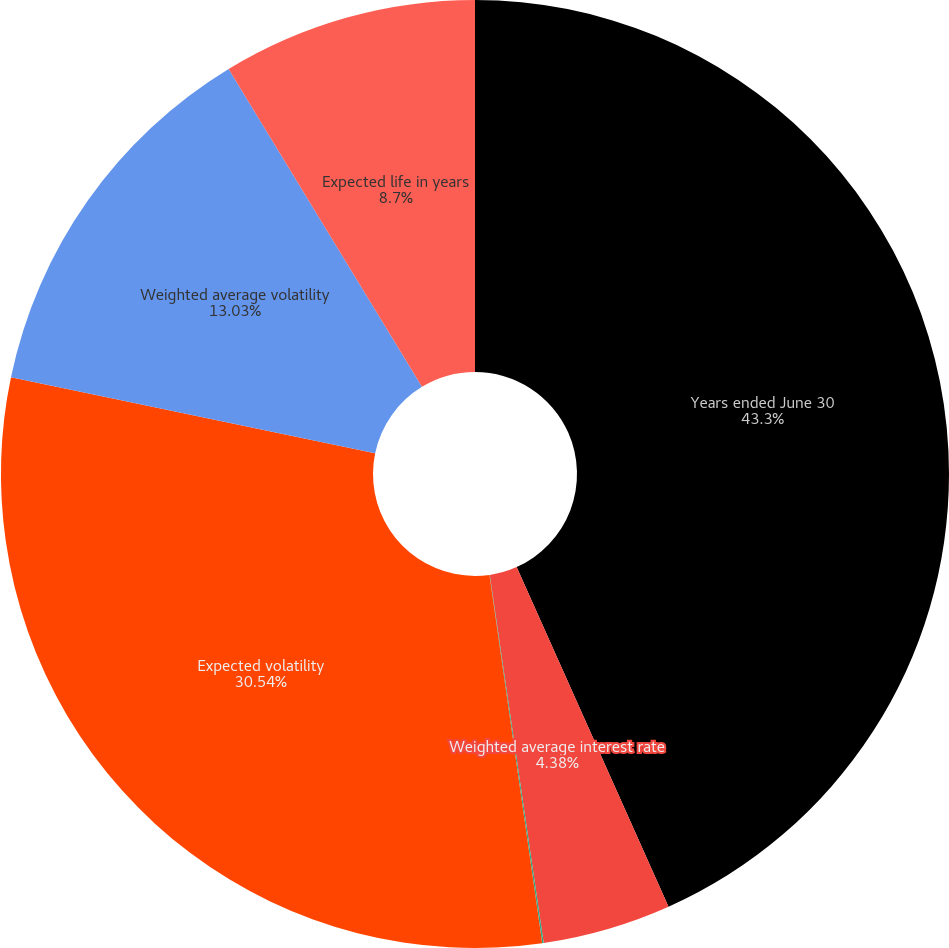Convert chart. <chart><loc_0><loc_0><loc_500><loc_500><pie_chart><fcel>Years ended June 30<fcel>Weighted average interest rate<fcel>Dividend yield<fcel>Expected volatility<fcel>Weighted average volatility<fcel>Expected life in years<nl><fcel>43.31%<fcel>4.38%<fcel>0.05%<fcel>30.54%<fcel>13.03%<fcel>8.7%<nl></chart> 